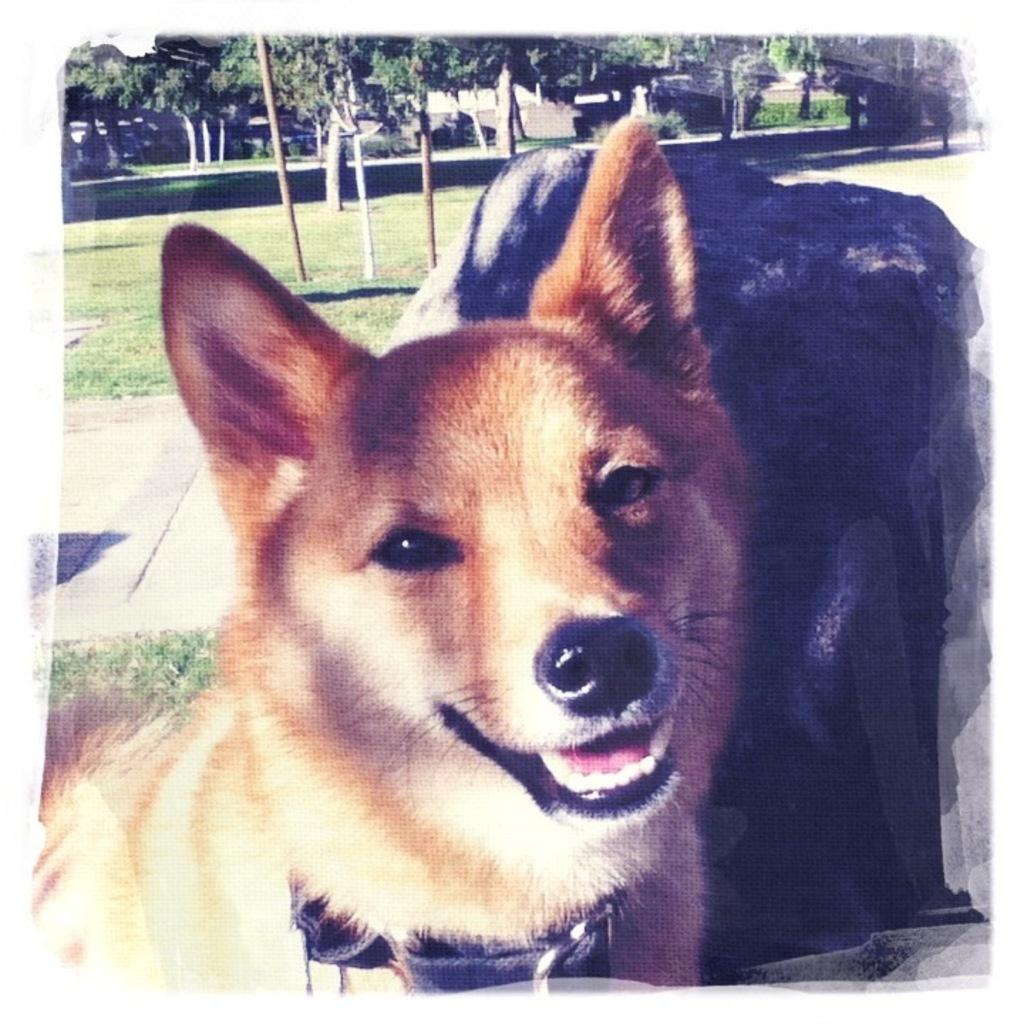What type of animal can be seen in the image? There is a dog in the image. What is visible in the background of the image? There is grass and trees in the background of the image. What type of chain is the dog pulling in the image? There is no chain present in the image; the dog is not pulling anything. 